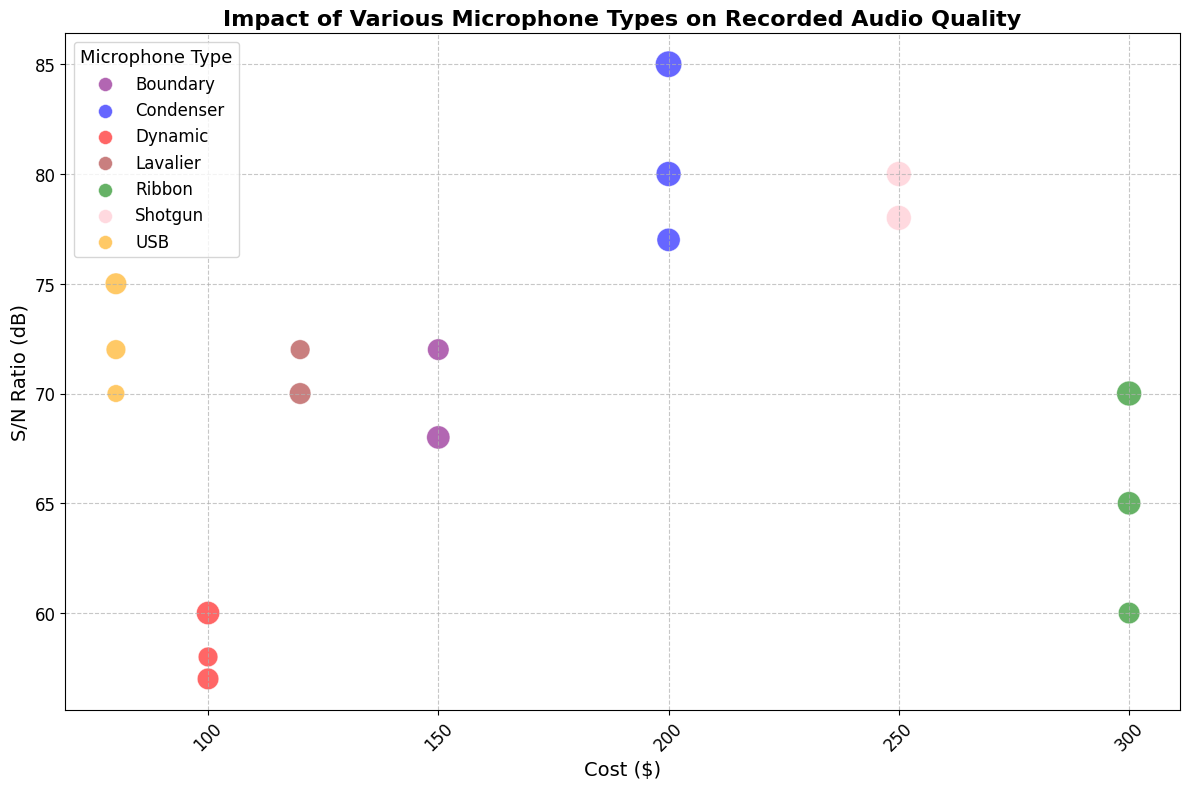What microphone type has the highest Signal-to-Noise Ratio (S/N Ratio)? Look for the microphone type with the highest position on the y-axis, representing S/N Ratio. The microphone type at the highest point has an S/N Ratio of 85 dB.
Answer: Condenser Which recording environment features the most variance in Impact on Audio Quality for condenser microphones? Observe the y-axis positions of the bubbles within each recording environment for condenser microphones. Look for environments with the widest range of positions. Both Studio and Live environments have significant variances, but the Live environment has an Impact on Audio Quality between 8 and 9 (closer).
Answer: Studio How does the cost of boundary microphones in the Studio environment compare to other environments? Identify the boundary microphones in the Studio environment by their purple color. Compare their x-axis position (cost) with boundary microphones in other environments. In the Studio environment, the cost is 150 dollars which is the same as in the Conference_Room environment.
Answer: Same as Conference_Room What is the average Impact on Audio Quality for USB microphones? Identify the bubble sizes for all USB microphones and calculate the average of their respective values. USB microphones have impact scores of 6, 5, and 4. (6 + 5 + 4)/3 = 5.
Answer: 5 Among the ribbon microphones, which recording environment offers the highest Impact on Audio Quality? Compare the bubble sizes of ribbon microphones across different environments. The largest bubble, which corresponds to the highest impact value, is in the Studio environment with an Impact on Audio Quality of 8.
Answer: Studio Which microphone type in the Live environment has the lowest Signal-to-Noise Ratio (S/N Ratio)? Identify all microphones in the Live environment by checking their labels. Then find the microphone type with the lowest y-position, representing S/N Ratio. Dynamic microphones in the Live environment have the lowest S/N Ratio with 58 dB.
Answer: Dynamic By how much does the S/N Ratio of the Condenser microphone in the Live environment exceed that of a Dynamic microphone in the Studio environment? Find the S/N Ratio for both microphones: Condenser in Live (80 dB) and Dynamic in Studio (60 dB). Subtract the smaller value from the larger one: 80 - 60 = 20 dB.
Answer: 20 dB Which microphone type typically costs the most and generally has a high Impact on Audio Quality? Look at the x-axis for the highest cost and check the corresponding bubble sizes. Ribbon microphones, with costs reaching up to 300 dollars, generally have high Impact on Audio Quality scores (7 and 8).
Answer: Ribbon Between a lavalier microphone in the Conference_Room environment and a USB one in the Studio, which has better Impact on Audio Quality? Compare the bubble sizes (representing Impact on Audio Quality) for both microphones. The lavalier microphone in Conference_Room has an Impact on Audio Quality of 6, while the USB one in Studio has an Impact on Audio Quality of 6 too.
Answer: Equal Which environment has the highest variation in S/N Ratios for condenser microphones? Compare environments by noting the range of y-axis positions for each condenser microphone. The Studio environment shows the highest variation in S/N Ratios for condenser microphones (77 to 85 dB).
Answer: Studio 